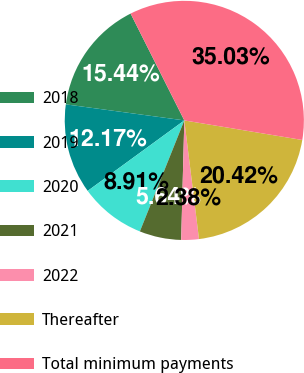Convert chart. <chart><loc_0><loc_0><loc_500><loc_500><pie_chart><fcel>2018<fcel>2019<fcel>2020<fcel>2021<fcel>2022<fcel>Thereafter<fcel>Total minimum payments<nl><fcel>15.44%<fcel>12.17%<fcel>8.91%<fcel>5.64%<fcel>2.38%<fcel>20.42%<fcel>35.03%<nl></chart> 